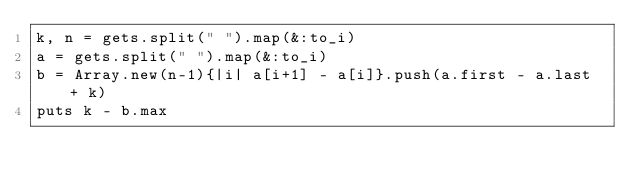Convert code to text. <code><loc_0><loc_0><loc_500><loc_500><_Ruby_>k, n = gets.split(" ").map(&:to_i)
a = gets.split(" ").map(&:to_i)
b = Array.new(n-1){|i| a[i+1] - a[i]}.push(a.first - a.last + k)
puts k - b.max
</code> 